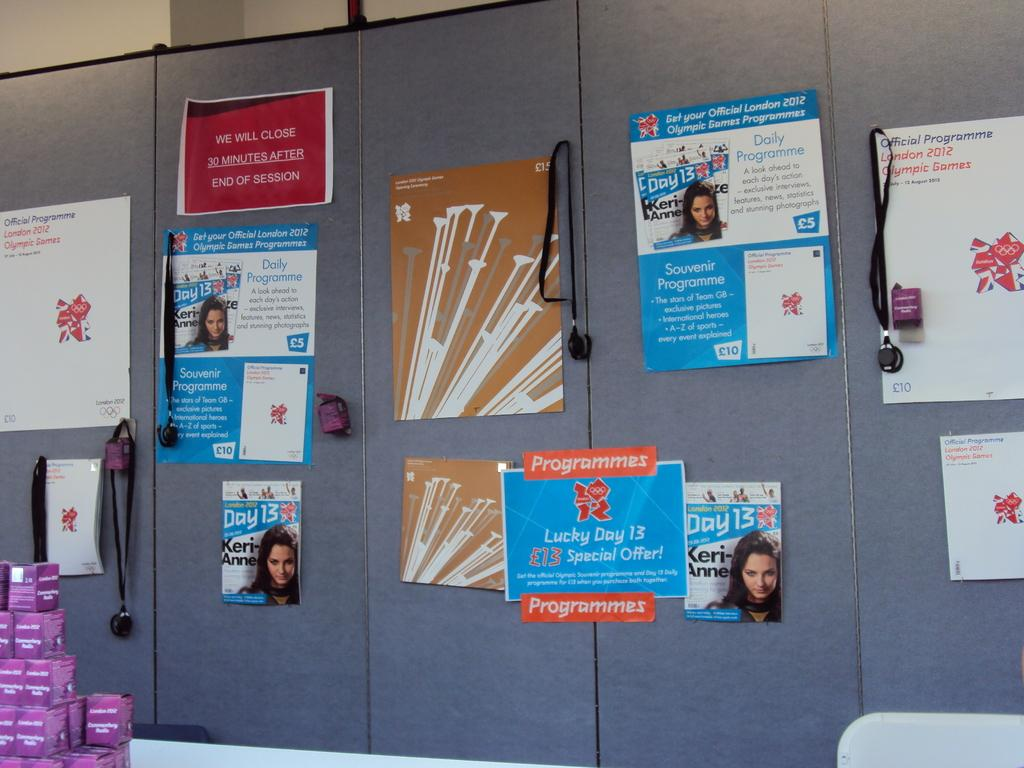<image>
Provide a brief description of the given image. A wall covered with notices including one that says Lucky day 13 special offer. 